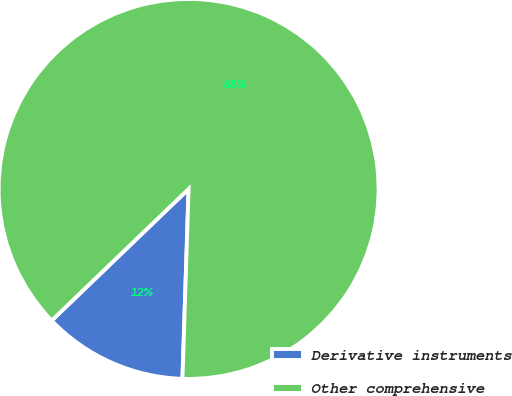Convert chart. <chart><loc_0><loc_0><loc_500><loc_500><pie_chart><fcel>Derivative instruments<fcel>Other comprehensive<nl><fcel>12.3%<fcel>87.7%<nl></chart> 